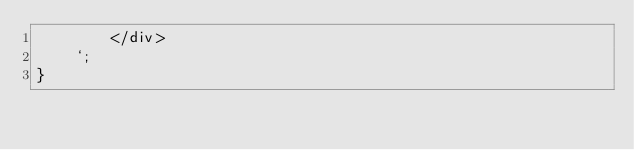<code> <loc_0><loc_0><loc_500><loc_500><_JavaScript_>        </div>
    `;
}
</code> 